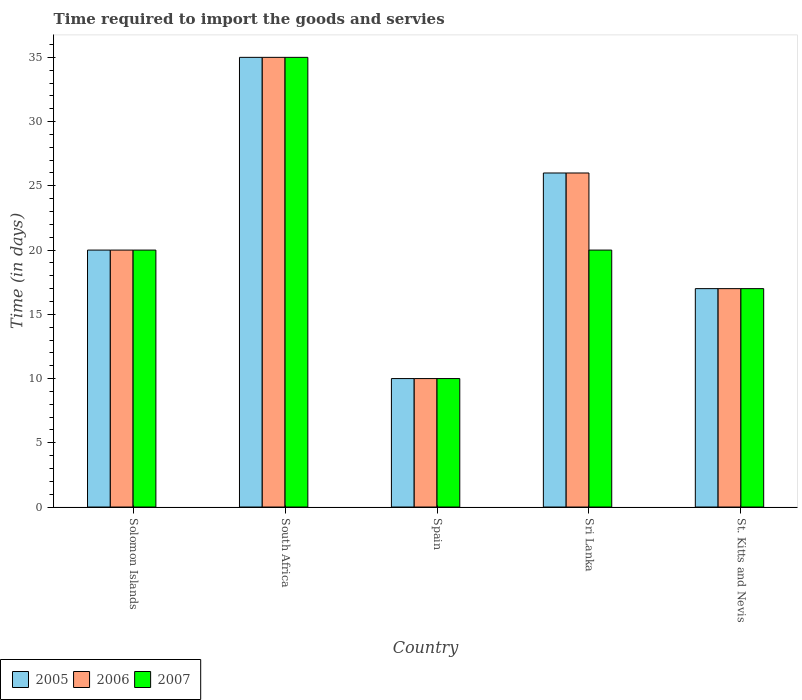Are the number of bars per tick equal to the number of legend labels?
Offer a very short reply. Yes. How many bars are there on the 3rd tick from the left?
Your answer should be very brief. 3. What is the label of the 1st group of bars from the left?
Make the answer very short. Solomon Islands. In which country was the number of days required to import the goods and services in 2006 maximum?
Provide a short and direct response. South Africa. What is the total number of days required to import the goods and services in 2007 in the graph?
Ensure brevity in your answer.  102. What is the difference between the number of days required to import the goods and services in 2007 in Sri Lanka and the number of days required to import the goods and services in 2006 in Spain?
Your answer should be very brief. 10. What is the average number of days required to import the goods and services in 2005 per country?
Keep it short and to the point. 21.6. In how many countries, is the number of days required to import the goods and services in 2006 greater than 10 days?
Your response must be concise. 4. What is the ratio of the number of days required to import the goods and services in 2005 in Spain to that in Sri Lanka?
Provide a short and direct response. 0.38. Is the number of days required to import the goods and services in 2006 in Solomon Islands less than that in Spain?
Provide a succinct answer. No. What is the difference between the highest and the lowest number of days required to import the goods and services in 2006?
Your response must be concise. 25. In how many countries, is the number of days required to import the goods and services in 2006 greater than the average number of days required to import the goods and services in 2006 taken over all countries?
Your response must be concise. 2. What does the 3rd bar from the right in St. Kitts and Nevis represents?
Ensure brevity in your answer.  2005. Does the graph contain grids?
Offer a terse response. No. Where does the legend appear in the graph?
Ensure brevity in your answer.  Bottom left. How many legend labels are there?
Provide a short and direct response. 3. What is the title of the graph?
Make the answer very short. Time required to import the goods and servies. What is the label or title of the X-axis?
Offer a terse response. Country. What is the label or title of the Y-axis?
Keep it short and to the point. Time (in days). What is the Time (in days) of 2005 in Solomon Islands?
Make the answer very short. 20. What is the Time (in days) of 2007 in Solomon Islands?
Your response must be concise. 20. What is the Time (in days) of 2005 in South Africa?
Your answer should be compact. 35. What is the Time (in days) of 2005 in Spain?
Your answer should be compact. 10. What is the Time (in days) of 2007 in Sri Lanka?
Keep it short and to the point. 20. What is the Time (in days) of 2005 in St. Kitts and Nevis?
Offer a very short reply. 17. What is the Time (in days) of 2006 in St. Kitts and Nevis?
Your answer should be very brief. 17. Across all countries, what is the maximum Time (in days) in 2006?
Offer a very short reply. 35. Across all countries, what is the maximum Time (in days) of 2007?
Give a very brief answer. 35. Across all countries, what is the minimum Time (in days) of 2007?
Give a very brief answer. 10. What is the total Time (in days) in 2005 in the graph?
Your answer should be very brief. 108. What is the total Time (in days) of 2006 in the graph?
Offer a terse response. 108. What is the total Time (in days) in 2007 in the graph?
Provide a succinct answer. 102. What is the difference between the Time (in days) of 2007 in Solomon Islands and that in Spain?
Provide a succinct answer. 10. What is the difference between the Time (in days) of 2006 in Solomon Islands and that in Sri Lanka?
Offer a very short reply. -6. What is the difference between the Time (in days) in 2007 in Solomon Islands and that in Sri Lanka?
Offer a very short reply. 0. What is the difference between the Time (in days) of 2005 in Solomon Islands and that in St. Kitts and Nevis?
Offer a very short reply. 3. What is the difference between the Time (in days) of 2007 in Solomon Islands and that in St. Kitts and Nevis?
Provide a succinct answer. 3. What is the difference between the Time (in days) in 2006 in South Africa and that in Sri Lanka?
Give a very brief answer. 9. What is the difference between the Time (in days) of 2005 in South Africa and that in St. Kitts and Nevis?
Provide a succinct answer. 18. What is the difference between the Time (in days) of 2007 in South Africa and that in St. Kitts and Nevis?
Offer a terse response. 18. What is the difference between the Time (in days) in 2006 in Spain and that in Sri Lanka?
Your answer should be compact. -16. What is the difference between the Time (in days) in 2006 in Spain and that in St. Kitts and Nevis?
Keep it short and to the point. -7. What is the difference between the Time (in days) in 2007 in Sri Lanka and that in St. Kitts and Nevis?
Offer a terse response. 3. What is the difference between the Time (in days) of 2005 in Solomon Islands and the Time (in days) of 2007 in South Africa?
Offer a very short reply. -15. What is the difference between the Time (in days) of 2005 in Solomon Islands and the Time (in days) of 2006 in Spain?
Your answer should be compact. 10. What is the difference between the Time (in days) of 2005 in Solomon Islands and the Time (in days) of 2007 in Spain?
Offer a terse response. 10. What is the difference between the Time (in days) in 2006 in Solomon Islands and the Time (in days) in 2007 in Spain?
Make the answer very short. 10. What is the difference between the Time (in days) in 2005 in Solomon Islands and the Time (in days) in 2006 in Sri Lanka?
Ensure brevity in your answer.  -6. What is the difference between the Time (in days) of 2005 in Solomon Islands and the Time (in days) of 2007 in Sri Lanka?
Your response must be concise. 0. What is the difference between the Time (in days) in 2005 in Solomon Islands and the Time (in days) in 2007 in St. Kitts and Nevis?
Offer a very short reply. 3. What is the difference between the Time (in days) in 2005 in South Africa and the Time (in days) in 2006 in Spain?
Give a very brief answer. 25. What is the difference between the Time (in days) of 2005 in South Africa and the Time (in days) of 2007 in Spain?
Offer a terse response. 25. What is the difference between the Time (in days) of 2005 in South Africa and the Time (in days) of 2006 in Sri Lanka?
Make the answer very short. 9. What is the difference between the Time (in days) in 2005 in South Africa and the Time (in days) in 2007 in Sri Lanka?
Keep it short and to the point. 15. What is the difference between the Time (in days) of 2006 in South Africa and the Time (in days) of 2007 in Sri Lanka?
Ensure brevity in your answer.  15. What is the difference between the Time (in days) of 2005 in South Africa and the Time (in days) of 2007 in St. Kitts and Nevis?
Offer a very short reply. 18. What is the difference between the Time (in days) in 2006 in South Africa and the Time (in days) in 2007 in St. Kitts and Nevis?
Offer a terse response. 18. What is the difference between the Time (in days) in 2005 in Spain and the Time (in days) in 2006 in Sri Lanka?
Keep it short and to the point. -16. What is the difference between the Time (in days) of 2005 in Spain and the Time (in days) of 2007 in Sri Lanka?
Provide a short and direct response. -10. What is the difference between the Time (in days) of 2006 in Spain and the Time (in days) of 2007 in Sri Lanka?
Provide a short and direct response. -10. What is the difference between the Time (in days) of 2006 in Spain and the Time (in days) of 2007 in St. Kitts and Nevis?
Make the answer very short. -7. What is the difference between the Time (in days) in 2005 in Sri Lanka and the Time (in days) in 2006 in St. Kitts and Nevis?
Keep it short and to the point. 9. What is the difference between the Time (in days) of 2005 in Sri Lanka and the Time (in days) of 2007 in St. Kitts and Nevis?
Offer a terse response. 9. What is the difference between the Time (in days) of 2006 in Sri Lanka and the Time (in days) of 2007 in St. Kitts and Nevis?
Your response must be concise. 9. What is the average Time (in days) in 2005 per country?
Your answer should be very brief. 21.6. What is the average Time (in days) in 2006 per country?
Offer a terse response. 21.6. What is the average Time (in days) in 2007 per country?
Offer a terse response. 20.4. What is the difference between the Time (in days) in 2005 and Time (in days) in 2007 in Solomon Islands?
Offer a terse response. 0. What is the difference between the Time (in days) in 2005 and Time (in days) in 2006 in South Africa?
Keep it short and to the point. 0. What is the difference between the Time (in days) of 2005 and Time (in days) of 2007 in South Africa?
Offer a very short reply. 0. What is the difference between the Time (in days) of 2006 and Time (in days) of 2007 in South Africa?
Your answer should be compact. 0. What is the difference between the Time (in days) in 2005 and Time (in days) in 2006 in Spain?
Your response must be concise. 0. What is the difference between the Time (in days) of 2006 and Time (in days) of 2007 in Spain?
Your answer should be compact. 0. What is the difference between the Time (in days) of 2005 and Time (in days) of 2006 in St. Kitts and Nevis?
Offer a terse response. 0. What is the difference between the Time (in days) in 2005 and Time (in days) in 2007 in St. Kitts and Nevis?
Your response must be concise. 0. What is the ratio of the Time (in days) of 2005 in Solomon Islands to that in South Africa?
Offer a terse response. 0.57. What is the ratio of the Time (in days) of 2006 in Solomon Islands to that in Spain?
Ensure brevity in your answer.  2. What is the ratio of the Time (in days) of 2005 in Solomon Islands to that in Sri Lanka?
Your answer should be very brief. 0.77. What is the ratio of the Time (in days) in 2006 in Solomon Islands to that in Sri Lanka?
Your answer should be compact. 0.77. What is the ratio of the Time (in days) in 2005 in Solomon Islands to that in St. Kitts and Nevis?
Give a very brief answer. 1.18. What is the ratio of the Time (in days) in 2006 in Solomon Islands to that in St. Kitts and Nevis?
Offer a terse response. 1.18. What is the ratio of the Time (in days) in 2007 in Solomon Islands to that in St. Kitts and Nevis?
Give a very brief answer. 1.18. What is the ratio of the Time (in days) in 2005 in South Africa to that in Sri Lanka?
Make the answer very short. 1.35. What is the ratio of the Time (in days) of 2006 in South Africa to that in Sri Lanka?
Ensure brevity in your answer.  1.35. What is the ratio of the Time (in days) in 2005 in South Africa to that in St. Kitts and Nevis?
Your answer should be very brief. 2.06. What is the ratio of the Time (in days) in 2006 in South Africa to that in St. Kitts and Nevis?
Give a very brief answer. 2.06. What is the ratio of the Time (in days) in 2007 in South Africa to that in St. Kitts and Nevis?
Your response must be concise. 2.06. What is the ratio of the Time (in days) of 2005 in Spain to that in Sri Lanka?
Give a very brief answer. 0.38. What is the ratio of the Time (in days) of 2006 in Spain to that in Sri Lanka?
Give a very brief answer. 0.38. What is the ratio of the Time (in days) of 2005 in Spain to that in St. Kitts and Nevis?
Keep it short and to the point. 0.59. What is the ratio of the Time (in days) of 2006 in Spain to that in St. Kitts and Nevis?
Offer a very short reply. 0.59. What is the ratio of the Time (in days) of 2007 in Spain to that in St. Kitts and Nevis?
Offer a very short reply. 0.59. What is the ratio of the Time (in days) in 2005 in Sri Lanka to that in St. Kitts and Nevis?
Your response must be concise. 1.53. What is the ratio of the Time (in days) in 2006 in Sri Lanka to that in St. Kitts and Nevis?
Your answer should be very brief. 1.53. What is the ratio of the Time (in days) of 2007 in Sri Lanka to that in St. Kitts and Nevis?
Provide a short and direct response. 1.18. What is the difference between the highest and the second highest Time (in days) in 2006?
Provide a short and direct response. 9. What is the difference between the highest and the second highest Time (in days) of 2007?
Ensure brevity in your answer.  15. What is the difference between the highest and the lowest Time (in days) of 2006?
Provide a succinct answer. 25. 